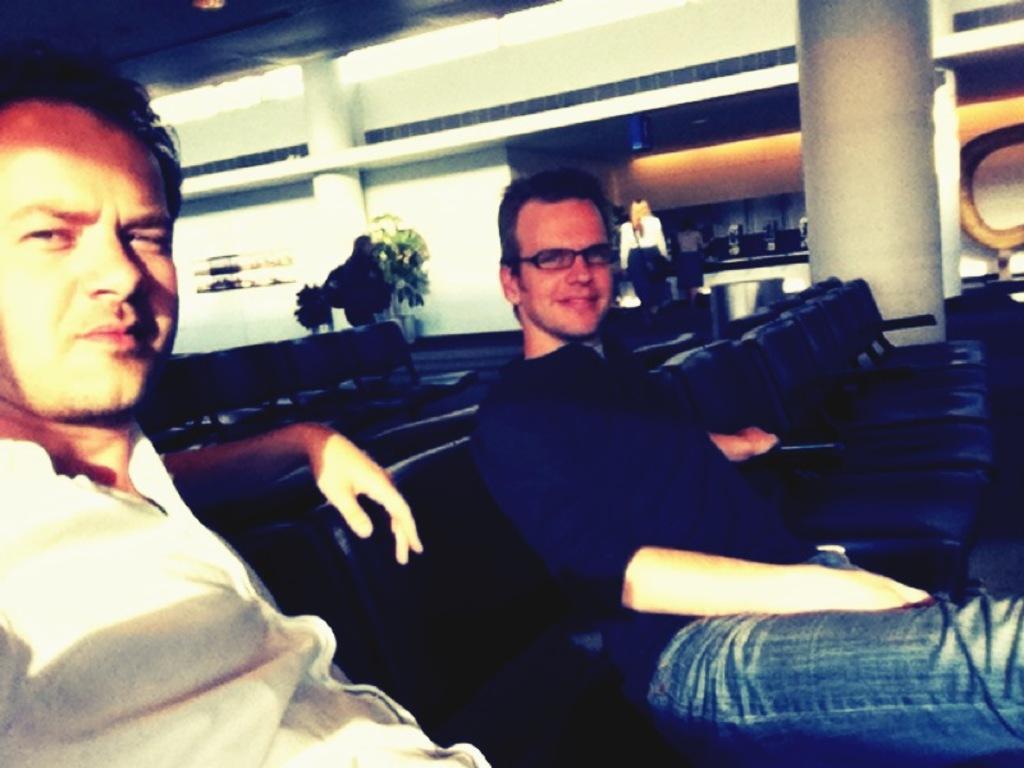In one or two sentences, can you explain what this image depicts? In this picture there are two persons sitting on the chair. There are two persons walking. At the back there is a building and there are plants and chairs. At the top there are lights. 